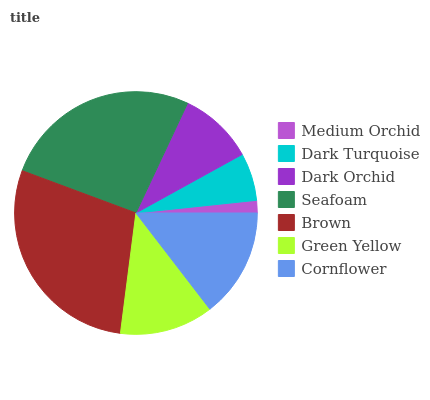Is Medium Orchid the minimum?
Answer yes or no. Yes. Is Brown the maximum?
Answer yes or no. Yes. Is Dark Turquoise the minimum?
Answer yes or no. No. Is Dark Turquoise the maximum?
Answer yes or no. No. Is Dark Turquoise greater than Medium Orchid?
Answer yes or no. Yes. Is Medium Orchid less than Dark Turquoise?
Answer yes or no. Yes. Is Medium Orchid greater than Dark Turquoise?
Answer yes or no. No. Is Dark Turquoise less than Medium Orchid?
Answer yes or no. No. Is Green Yellow the high median?
Answer yes or no. Yes. Is Green Yellow the low median?
Answer yes or no. Yes. Is Cornflower the high median?
Answer yes or no. No. Is Brown the low median?
Answer yes or no. No. 